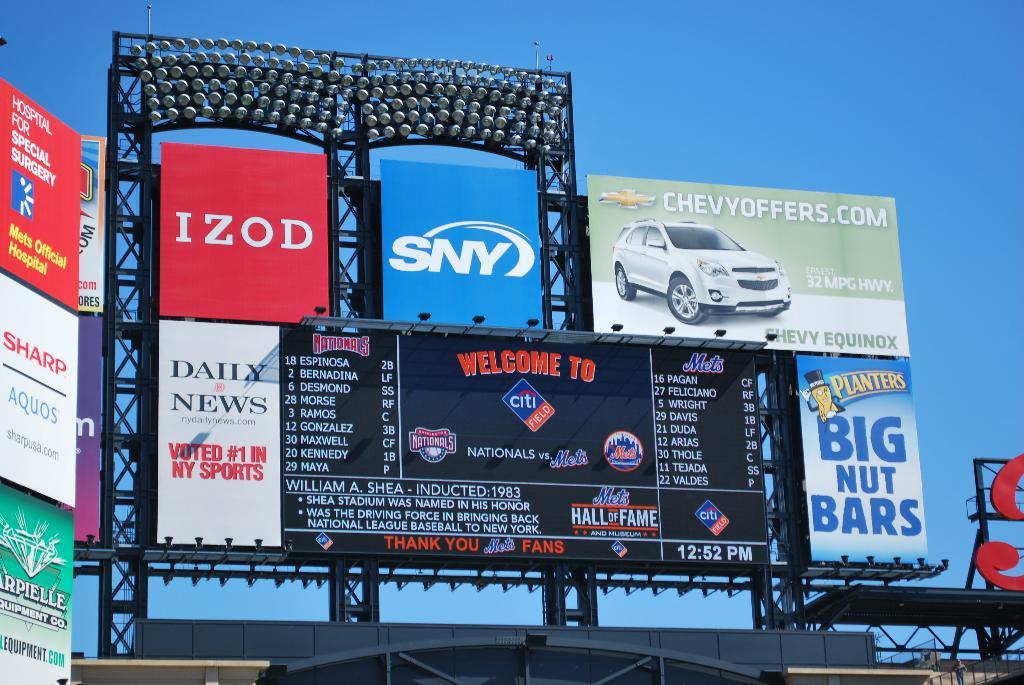What is the website for the car ad on the top lft?
Give a very brief answer. Chevyoffers.com. What news source is advertised?
Provide a short and direct response. Daily news. 